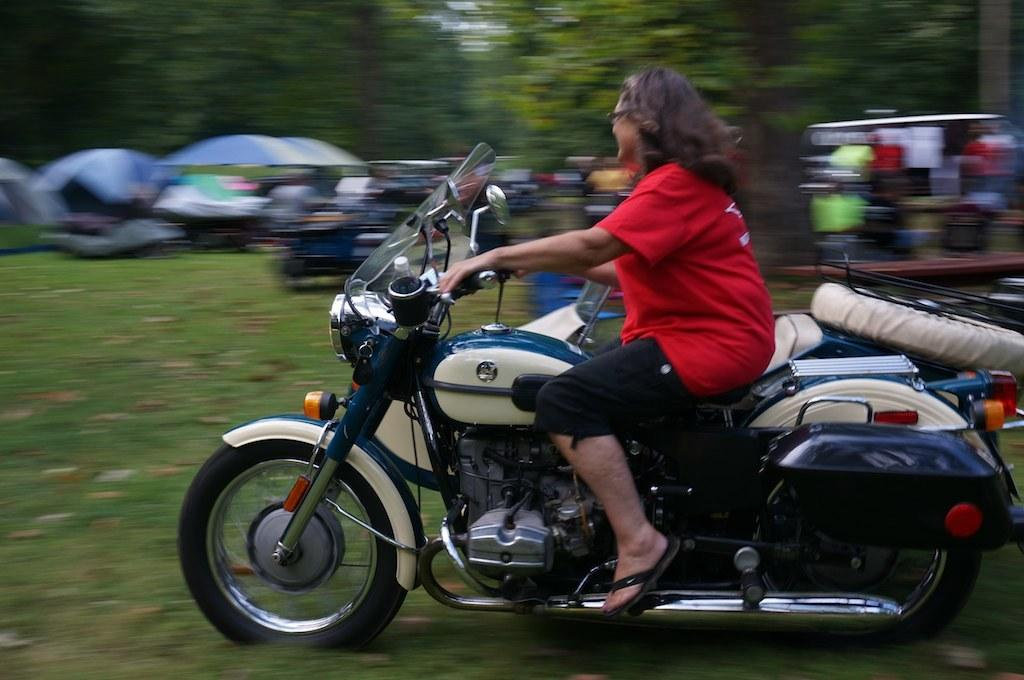What is the main subject of the image? There is a person in the image. What is the person doing in the image? The person is sitting on a bike. What can be seen in the background of the image? There are trees in the background of the image. What type of cracker is the person eating while riding the bike in the image? There is no cracker present in the image, and the person is not eating anything. 